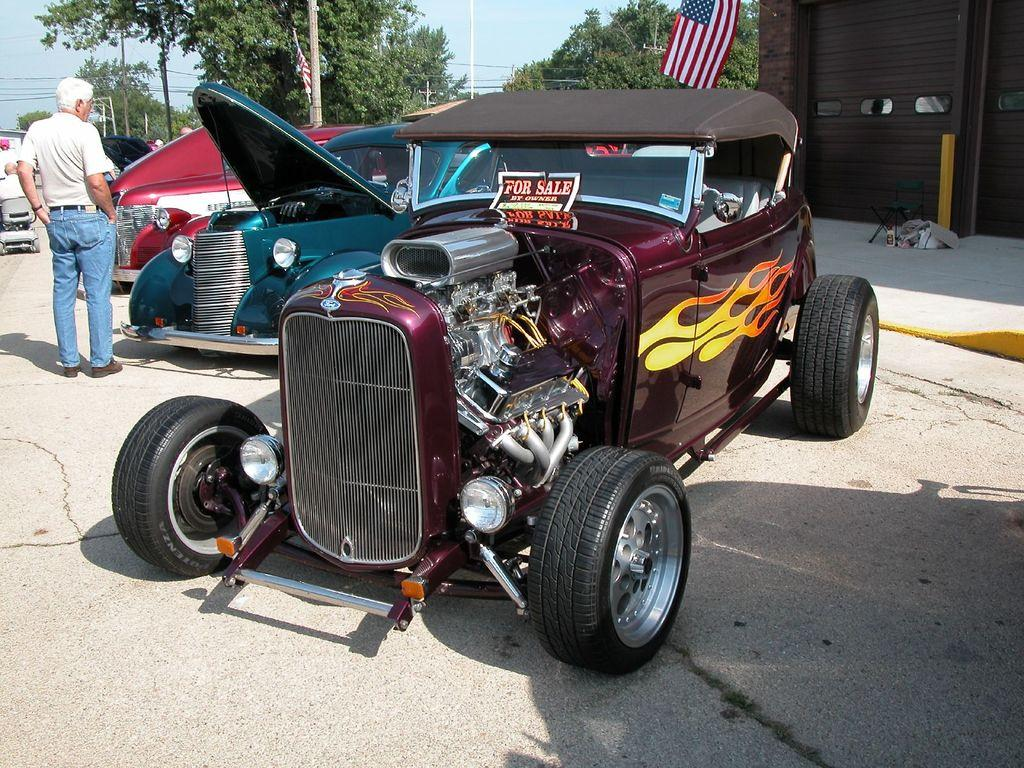What can be seen in the foreground of the picture? In the foreground of the picture, there are cars, people, a pavement, and a road. What is the condition of the sky in the picture? The sky is sunny in the picture. What can be seen in the background of the picture? In the background of the picture, there are trees, poles, flags, cables, and a building. What type of jam is being spread on the flag in the image? There is no jam or flag being spread with jam in the image. What time of day is it in the image? The time of day cannot be determined from the image, as there is no specific indication of the time. 